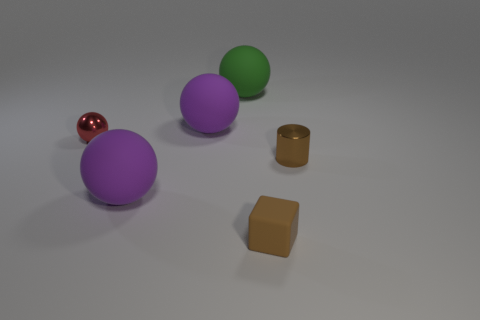Is the color of the rubber block the same as the metallic cylinder?
Ensure brevity in your answer.  Yes. What number of cylinders have the same size as the red ball?
Offer a very short reply. 1. Are there more large things in front of the cylinder than small cylinders on the left side of the tiny red ball?
Provide a short and direct response. Yes. What is the color of the large sphere that is in front of the brown thing behind the tiny brown matte object?
Offer a terse response. Purple. Do the red thing and the tiny brown cylinder have the same material?
Offer a very short reply. Yes. Are there any other tiny brown things of the same shape as the brown rubber thing?
Your response must be concise. No. Do the tiny thing that is on the left side of the small brown rubber object and the small cube have the same color?
Your answer should be compact. No. Does the matte thing that is on the right side of the large green object have the same size as the metallic thing that is left of the large green object?
Offer a very short reply. Yes. There is a green thing that is made of the same material as the block; what is its size?
Ensure brevity in your answer.  Large. What number of objects are in front of the small red thing and behind the tiny brown rubber object?
Your answer should be compact. 2. 